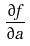<formula> <loc_0><loc_0><loc_500><loc_500>\frac { \partial f } { \partial a }</formula> 